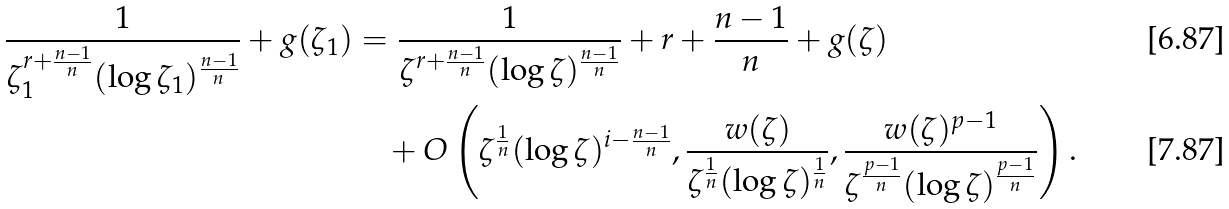<formula> <loc_0><loc_0><loc_500><loc_500>\frac { 1 } { \zeta _ { 1 } ^ { r + \frac { n - 1 } { n } } ( \log \zeta _ { 1 } ) ^ { \frac { n - 1 } { n } } } + g ( \zeta _ { 1 } ) & = \frac { 1 } { \zeta ^ { r + \frac { n - 1 } { n } } ( \log \zeta ) ^ { \frac { n - 1 } { n } } } + r + \frac { n - 1 } { n } + g ( \zeta ) \\ & \quad + O \left ( \zeta ^ { \frac { 1 } { n } } ( \log \zeta ) ^ { i - \frac { n - 1 } { n } } , \frac { w ( \zeta ) } { \zeta ^ { \frac { 1 } { n } } ( \log \zeta ) ^ { \frac { 1 } { n } } } , \frac { w ( \zeta ) ^ { p - 1 } } { \zeta ^ { \frac { p - 1 } { n } } ( \log \zeta ) ^ { \frac { p - 1 } { n } } } \right ) .</formula> 